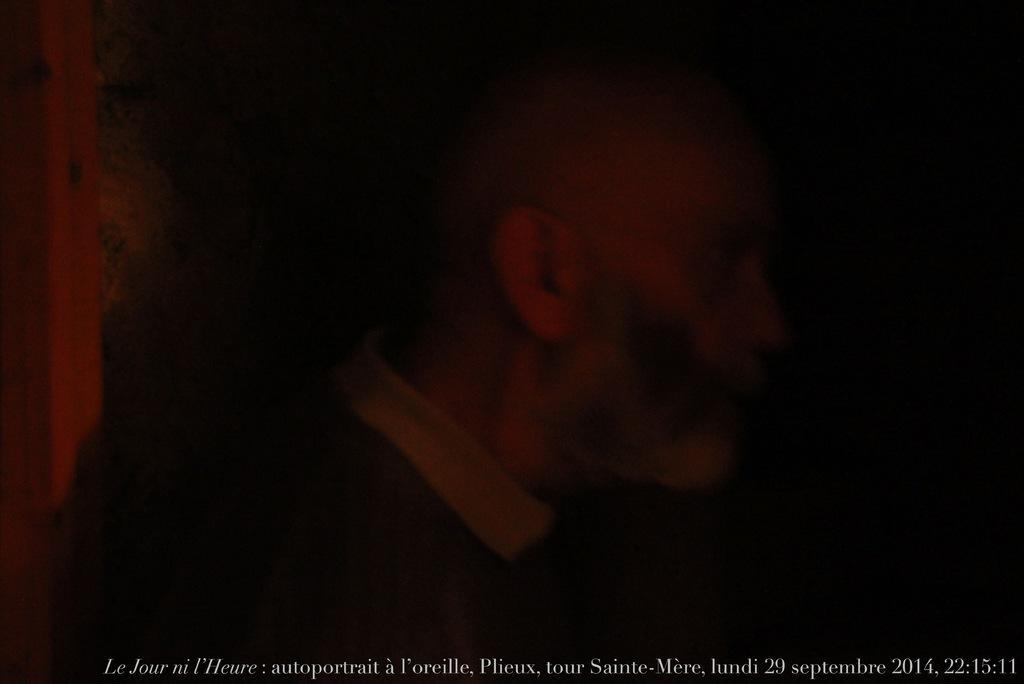In one or two sentences, can you explain what this image depicts? The picture has less light. In the center of a picture we can see a person. At the bottom there is a text, date and time. 